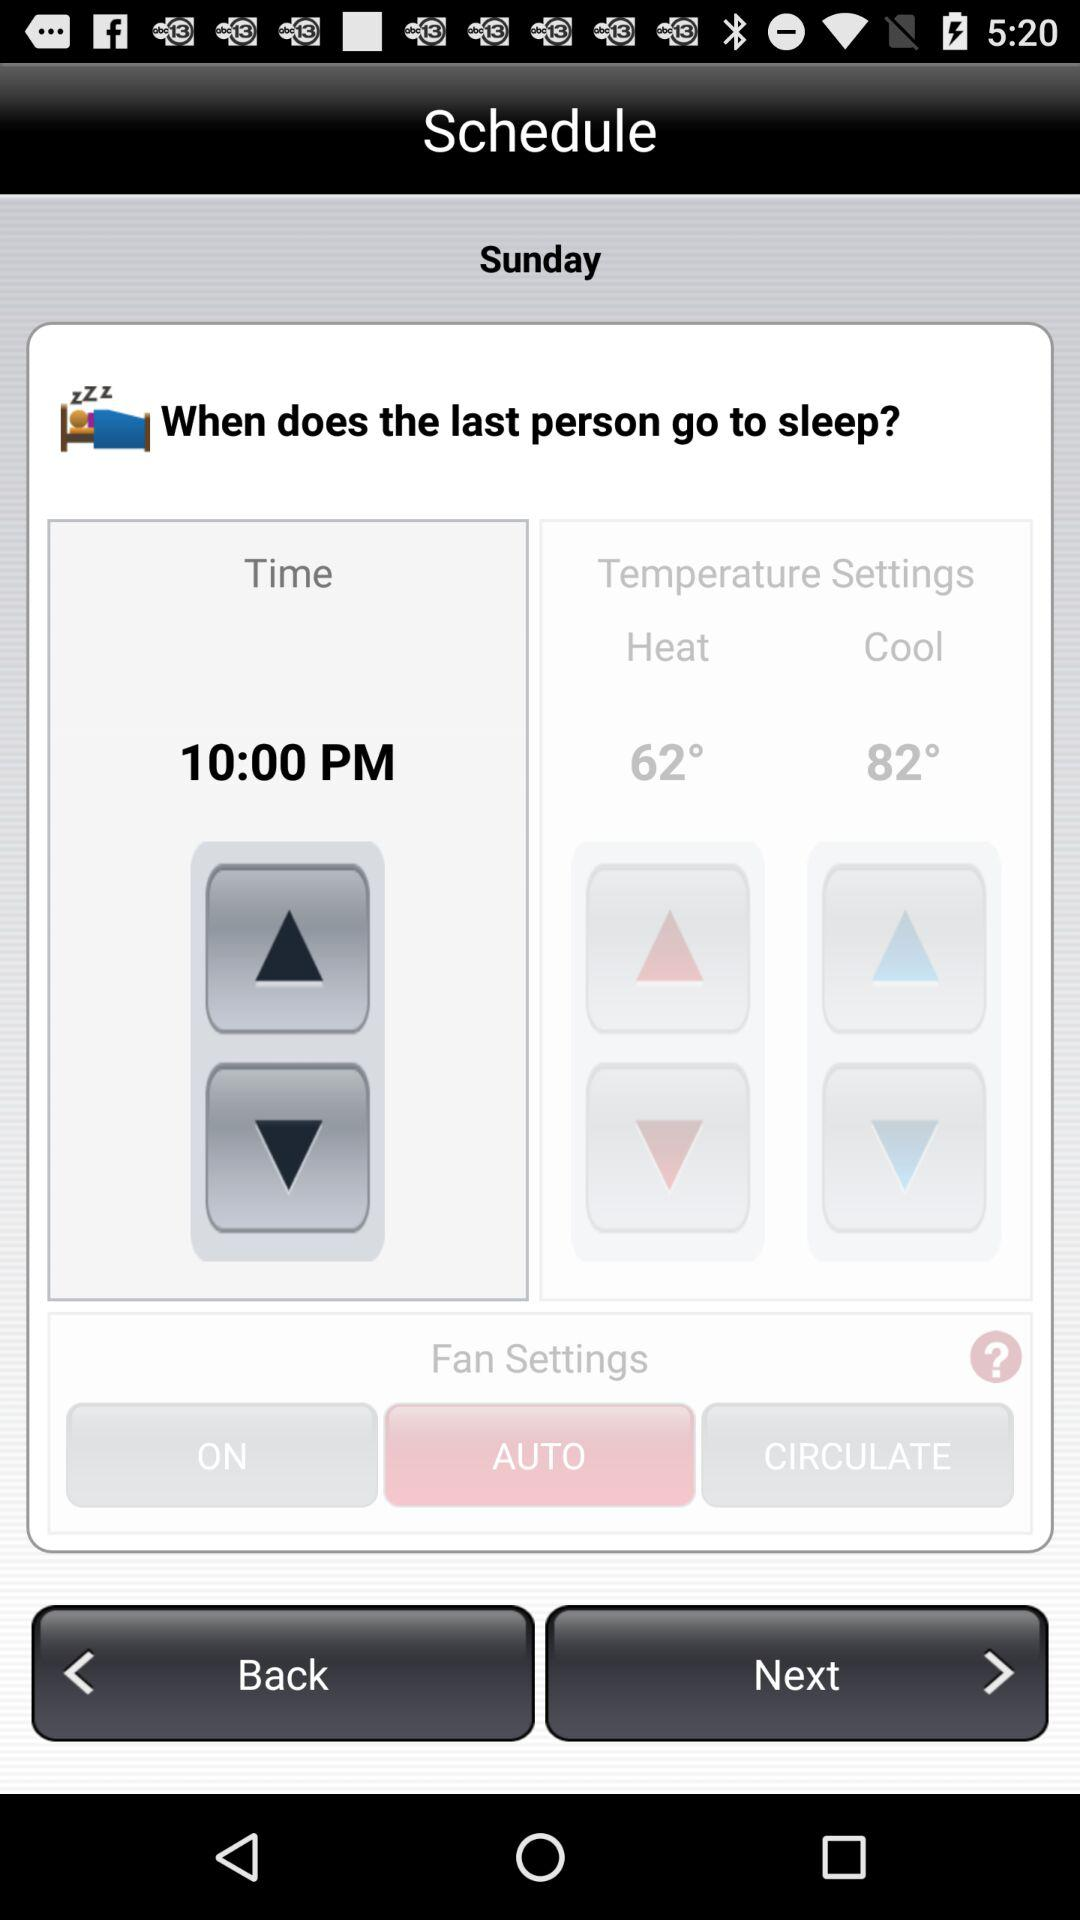What is the day? The day is Sunday. 